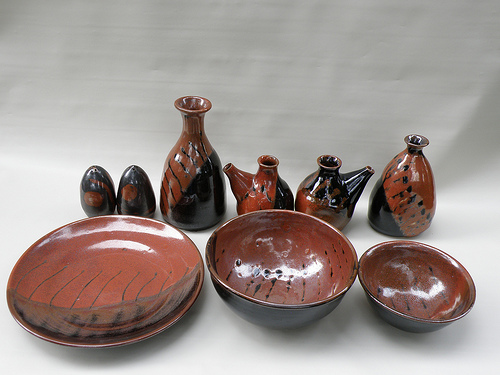Please provide a short description for this region: [0.01, 0.53, 0.42, 0.84]. The region defined by the coordinates [0.01, 0.53, 0.42, 0.84] contains a red plate. The plate's bright color makes it stand out boldly against the softer hues in the background. 